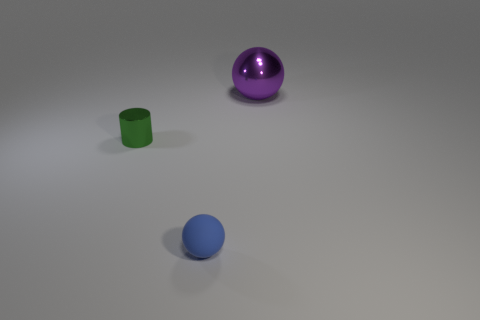There is a metal object behind the tiny green metal cylinder; is it the same size as the shiny object that is left of the shiny ball?
Ensure brevity in your answer.  No. How many large matte cubes are there?
Offer a very short reply. 0. What number of green cylinders have the same material as the purple sphere?
Your response must be concise. 1. Are there the same number of green objects on the right side of the purple object and shiny spheres?
Keep it short and to the point. No. There is a green shiny cylinder; is it the same size as the ball that is in front of the big purple object?
Provide a short and direct response. Yes. How many other objects are the same size as the green object?
Provide a succinct answer. 1. What number of other things are there of the same color as the large shiny object?
Provide a succinct answer. 0. Are there any other things that are the same size as the purple metallic sphere?
Provide a short and direct response. No. How many other objects are there of the same shape as the big purple shiny object?
Ensure brevity in your answer.  1. Do the cylinder and the shiny ball have the same size?
Ensure brevity in your answer.  No. 